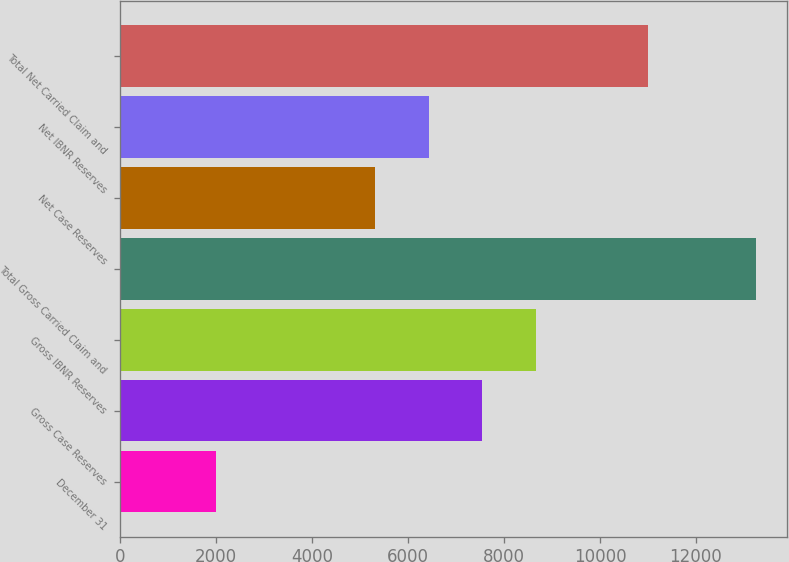<chart> <loc_0><loc_0><loc_500><loc_500><bar_chart><fcel>December 31<fcel>Gross Case Reserves<fcel>Gross IBNR Reserves<fcel>Total Gross Carried Claim and<fcel>Net Case Reserves<fcel>Net IBNR Reserves<fcel>Total Net Carried Claim and<nl><fcel>2009<fcel>7552.8<fcel>8676.2<fcel>13243<fcel>5306<fcel>6429.4<fcel>10997<nl></chart> 